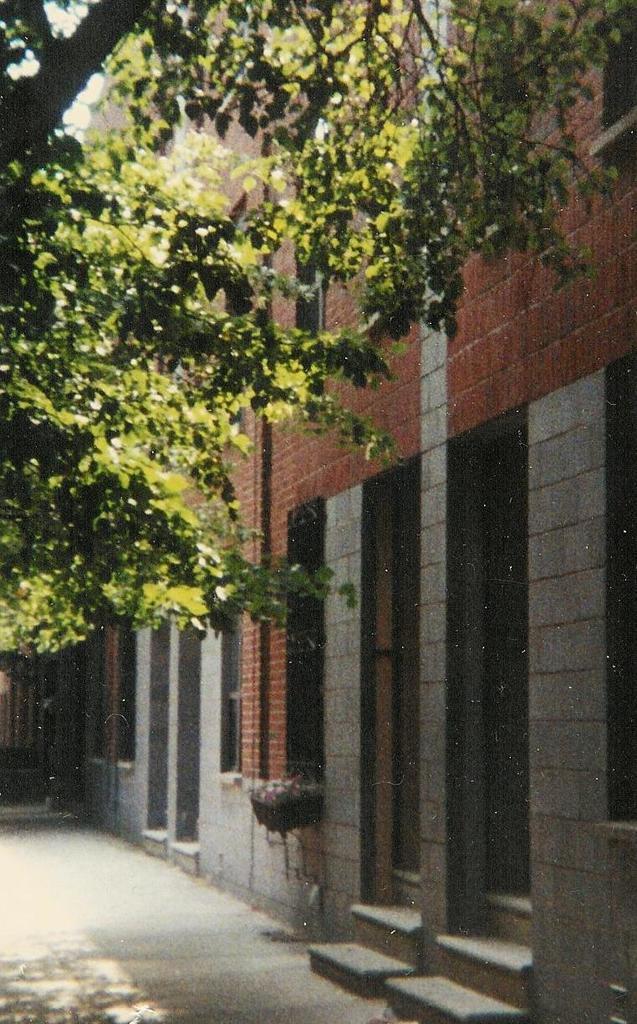Describe this image in one or two sentences. In this picture we can see the wall and a tree. At the bottom portion of the picture we can see the pathway. 